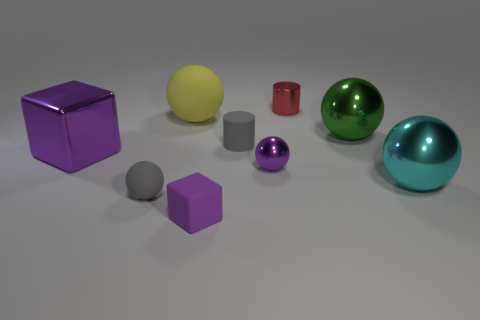The other sphere that is the same size as the purple metal sphere is what color?
Your answer should be very brief. Gray. Does the cyan metal sphere have the same size as the cylinder in front of the red shiny cylinder?
Your answer should be very brief. No. How many small matte things have the same color as the tiny metal cylinder?
Make the answer very short. 0. What number of objects are either small purple shiny spheres or metallic things that are right of the purple rubber block?
Offer a very short reply. 4. Is the size of the block that is in front of the gray sphere the same as the matte sphere behind the tiny gray cylinder?
Your answer should be compact. No. Are there any big cylinders that have the same material as the big cube?
Keep it short and to the point. No. What shape is the yellow rubber object?
Ensure brevity in your answer.  Sphere. What is the shape of the large metal object behind the gray rubber object right of the large yellow sphere?
Provide a short and direct response. Sphere. How many other objects are there of the same shape as the tiny red shiny object?
Give a very brief answer. 1. There is a object that is to the left of the matte sphere that is in front of the large purple block; what size is it?
Your answer should be very brief. Large. 